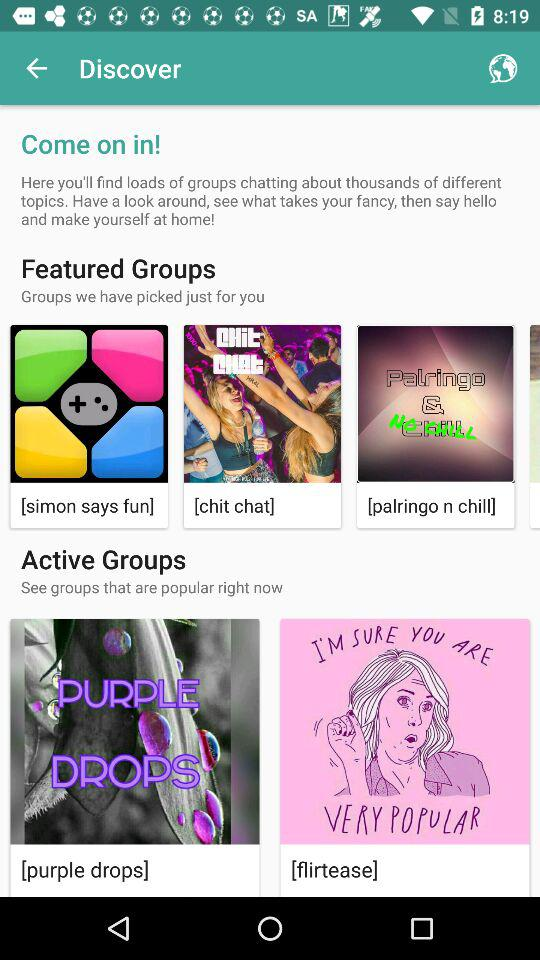Which category does "purple drops" belong to? "purple drops" belong to "Active Groups". 